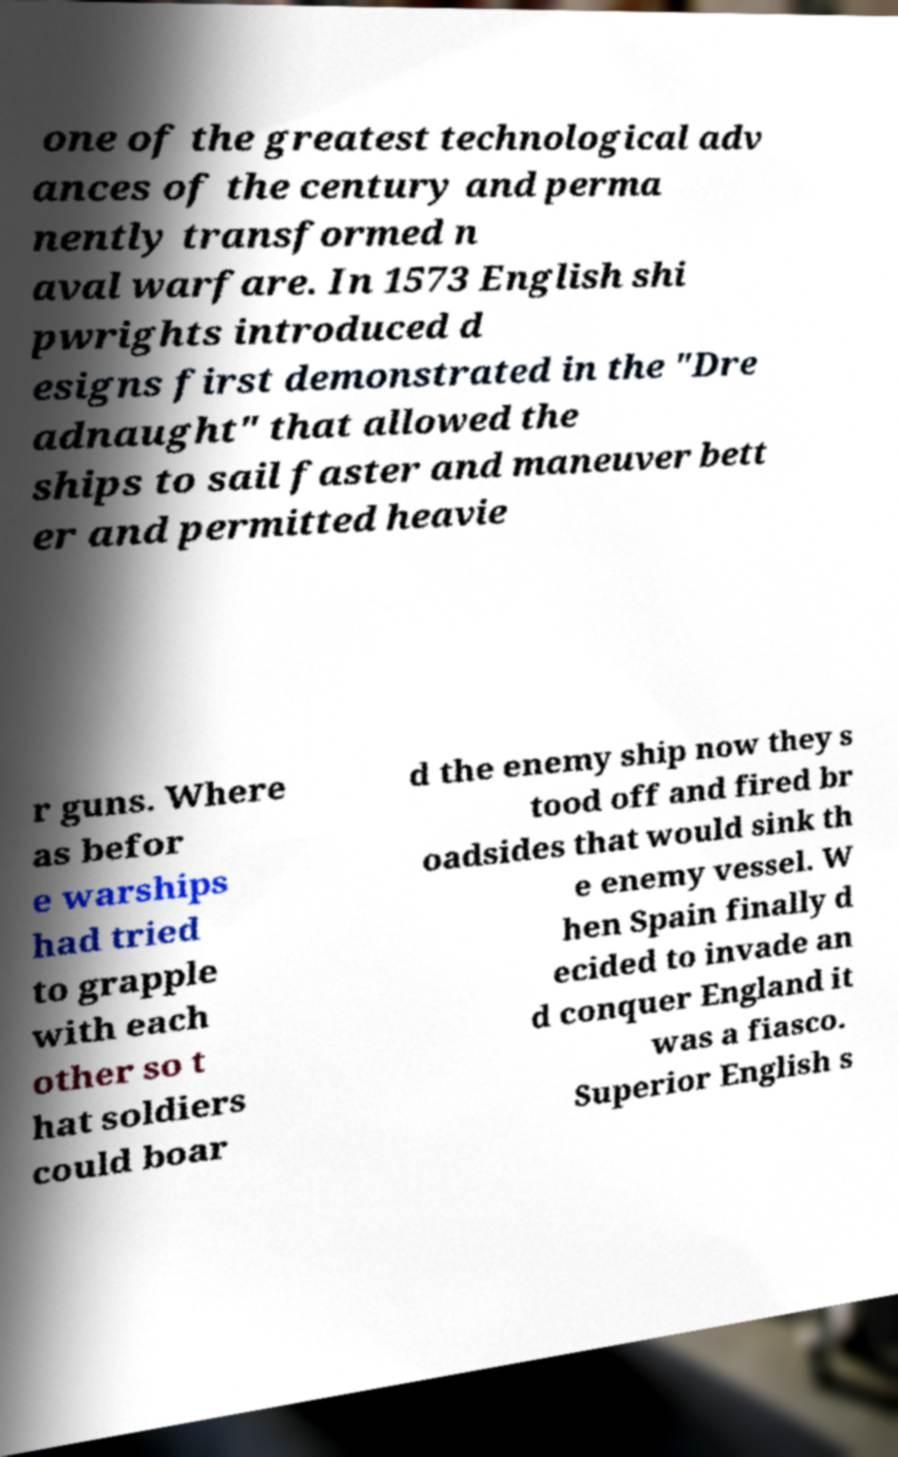Please read and relay the text visible in this image. What does it say? one of the greatest technological adv ances of the century and perma nently transformed n aval warfare. In 1573 English shi pwrights introduced d esigns first demonstrated in the "Dre adnaught" that allowed the ships to sail faster and maneuver bett er and permitted heavie r guns. Where as befor e warships had tried to grapple with each other so t hat soldiers could boar d the enemy ship now they s tood off and fired br oadsides that would sink th e enemy vessel. W hen Spain finally d ecided to invade an d conquer England it was a fiasco. Superior English s 